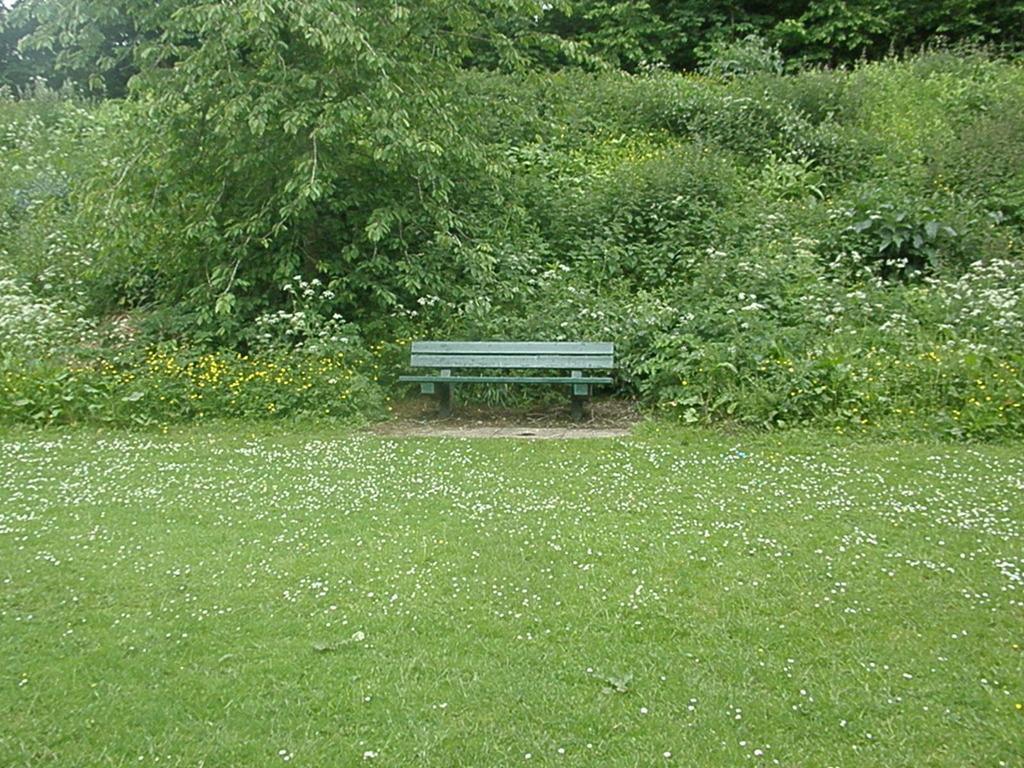In one or two sentences, can you explain what this image depicts? In this image there is a wooden bench, in front of the bench there's grass on the surface, behind the bench there are trees. 